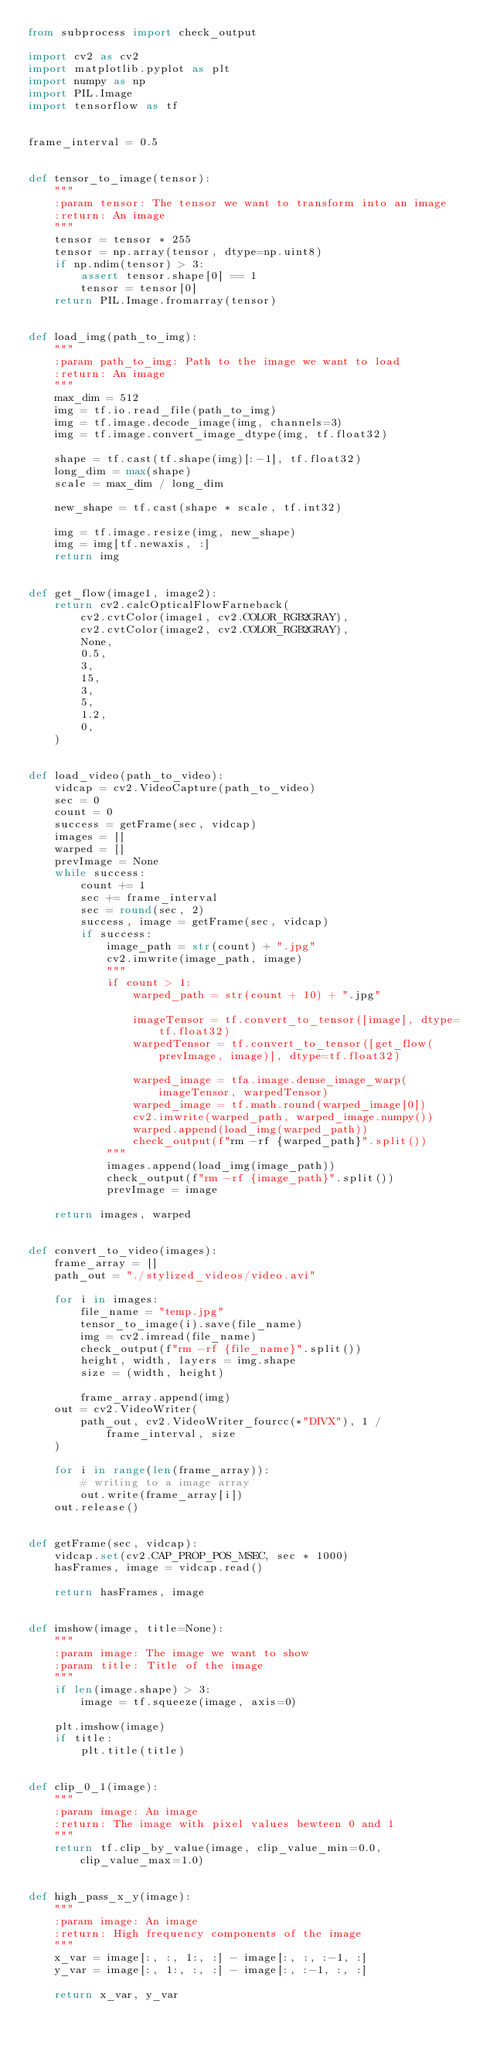<code> <loc_0><loc_0><loc_500><loc_500><_Python_>from subprocess import check_output

import cv2 as cv2
import matplotlib.pyplot as plt
import numpy as np
import PIL.Image
import tensorflow as tf


frame_interval = 0.5


def tensor_to_image(tensor):
    """
    :param tensor: The tensor we want to transform into an image
    :return: An image
    """
    tensor = tensor * 255
    tensor = np.array(tensor, dtype=np.uint8)
    if np.ndim(tensor) > 3:
        assert tensor.shape[0] == 1
        tensor = tensor[0]
    return PIL.Image.fromarray(tensor)


def load_img(path_to_img):
    """
    :param path_to_img: Path to the image we want to load
    :return: An image
    """
    max_dim = 512
    img = tf.io.read_file(path_to_img)
    img = tf.image.decode_image(img, channels=3)
    img = tf.image.convert_image_dtype(img, tf.float32)

    shape = tf.cast(tf.shape(img)[:-1], tf.float32)
    long_dim = max(shape)
    scale = max_dim / long_dim

    new_shape = tf.cast(shape * scale, tf.int32)

    img = tf.image.resize(img, new_shape)
    img = img[tf.newaxis, :]
    return img


def get_flow(image1, image2):
    return cv2.calcOpticalFlowFarneback(
        cv2.cvtColor(image1, cv2.COLOR_RGB2GRAY),
        cv2.cvtColor(image2, cv2.COLOR_RGB2GRAY),
        None,
        0.5,
        3,
        15,
        3,
        5,
        1.2,
        0,
    )


def load_video(path_to_video):
    vidcap = cv2.VideoCapture(path_to_video)
    sec = 0
    count = 0
    success = getFrame(sec, vidcap)
    images = []
    warped = []
    prevImage = None
    while success:
        count += 1
        sec += frame_interval
        sec = round(sec, 2)
        success, image = getFrame(sec, vidcap)
        if success:
            image_path = str(count) + ".jpg"
            cv2.imwrite(image_path, image)
            """
            if count > 1:
                warped_path = str(count + 10) + ".jpg"

                imageTensor = tf.convert_to_tensor([image], dtype=tf.float32)
                warpedTensor = tf.convert_to_tensor([get_flow(prevImage, image)], dtype=tf.float32)

                warped_image = tfa.image.dense_image_warp(imageTensor, warpedTensor)
                warped_image = tf.math.round(warped_image[0])
                cv2.imwrite(warped_path, warped_image.numpy())
                warped.append(load_img(warped_path))
                check_output(f"rm -rf {warped_path}".split())
            """
            images.append(load_img(image_path))
            check_output(f"rm -rf {image_path}".split())
            prevImage = image

    return images, warped


def convert_to_video(images):
    frame_array = []
    path_out = "./stylized_videos/video.avi"

    for i in images:
        file_name = "temp.jpg"
        tensor_to_image(i).save(file_name)
        img = cv2.imread(file_name)
        check_output(f"rm -rf {file_name}".split())
        height, width, layers = img.shape
        size = (width, height)

        frame_array.append(img)
    out = cv2.VideoWriter(
        path_out, cv2.VideoWriter_fourcc(*"DIVX"), 1 / frame_interval, size
    )

    for i in range(len(frame_array)):
        # writing to a image array
        out.write(frame_array[i])
    out.release()


def getFrame(sec, vidcap):
    vidcap.set(cv2.CAP_PROP_POS_MSEC, sec * 1000)
    hasFrames, image = vidcap.read()

    return hasFrames, image


def imshow(image, title=None):
    """
    :param image: The image we want to show
    :param title: Title of the image
    """
    if len(image.shape) > 3:
        image = tf.squeeze(image, axis=0)

    plt.imshow(image)
    if title:
        plt.title(title)


def clip_0_1(image):
    """
    :param image: An image
    :return: The image with pixel values bewteen 0 and 1
    """
    return tf.clip_by_value(image, clip_value_min=0.0, clip_value_max=1.0)


def high_pass_x_y(image):
    """
    :param image: An image
    :return: High frequency components of the image
    """
    x_var = image[:, :, 1:, :] - image[:, :, :-1, :]
    y_var = image[:, 1:, :, :] - image[:, :-1, :, :]

    return x_var, y_var
</code> 